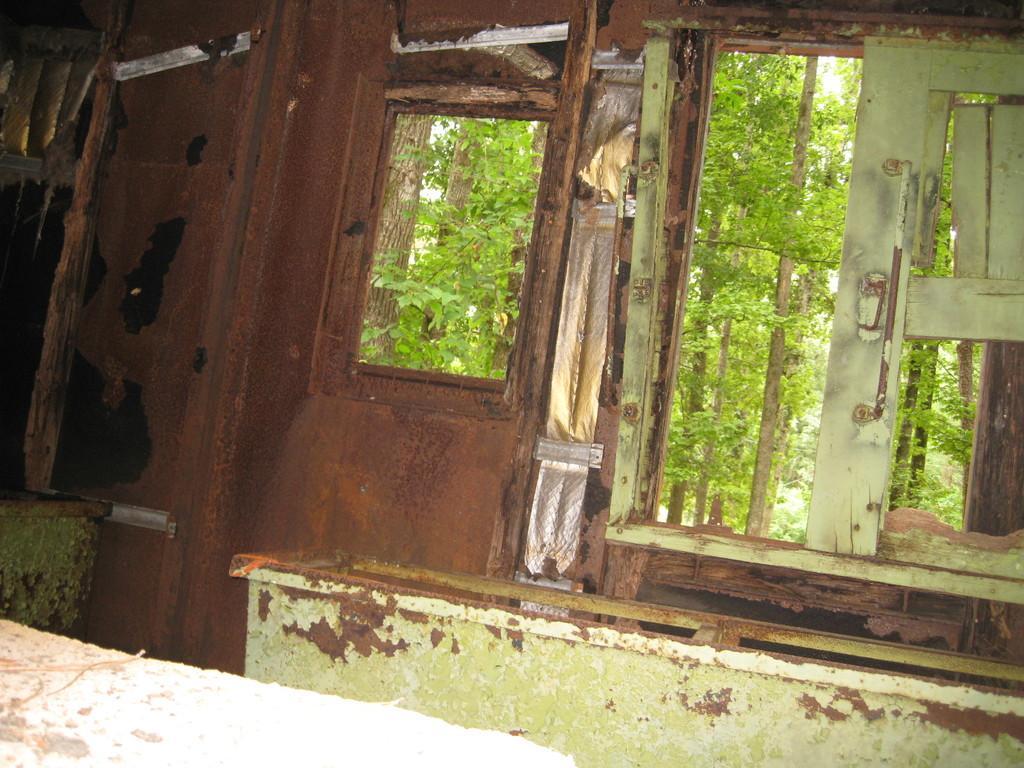Could you give a brief overview of what you see in this image? In this image we can see some windows, there are some doors and in the background of the image there are some trees. 